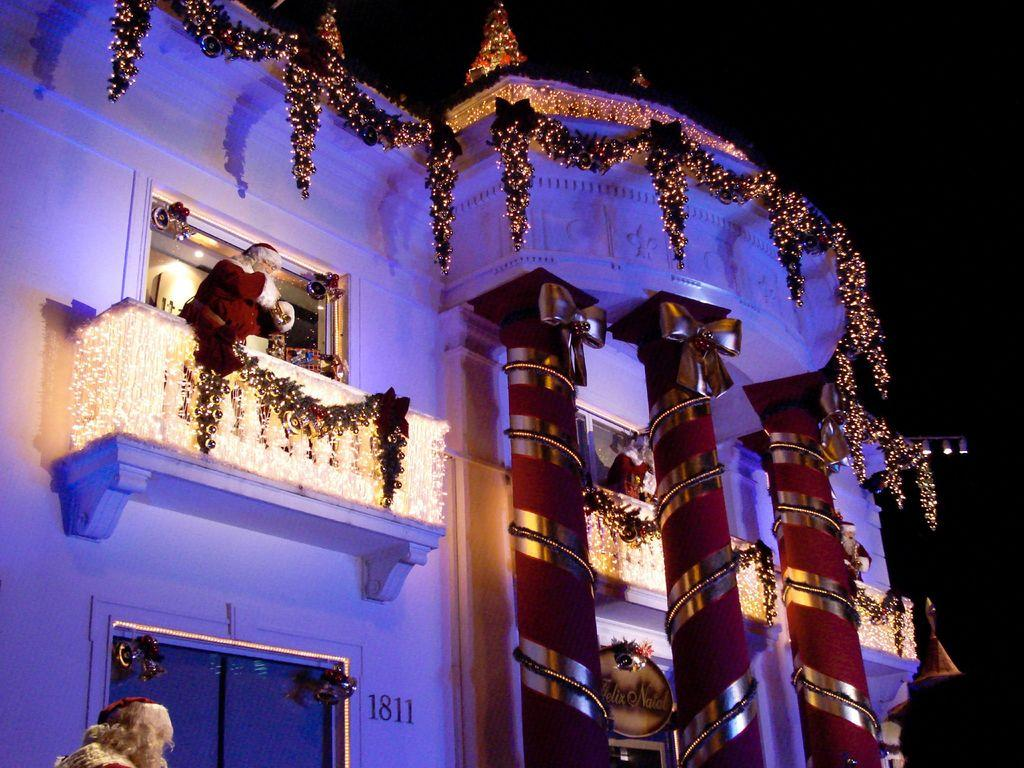What is the lighting condition in the image? The image is taken in a dark environment. What architectural features can be seen in the image? There are pillars in the image. What decorative elements are present in the image? Decorative items are present in the image. What holiday-related item is visible in the image? There is a Christmas tree in the image. What type of lighting is used in the image? LED lights are visible in the image. Who is present in the image? Santa Claus is present in the image. What type of sign or board is in the image? There is a board in the image. What type of structure is visible in the background? There is a building in the image. What is the color of the sky in the background? The sky in the background is dark. Can you see the mom walking on the sidewalk in the image? There is no mom or sidewalk present in the image. 